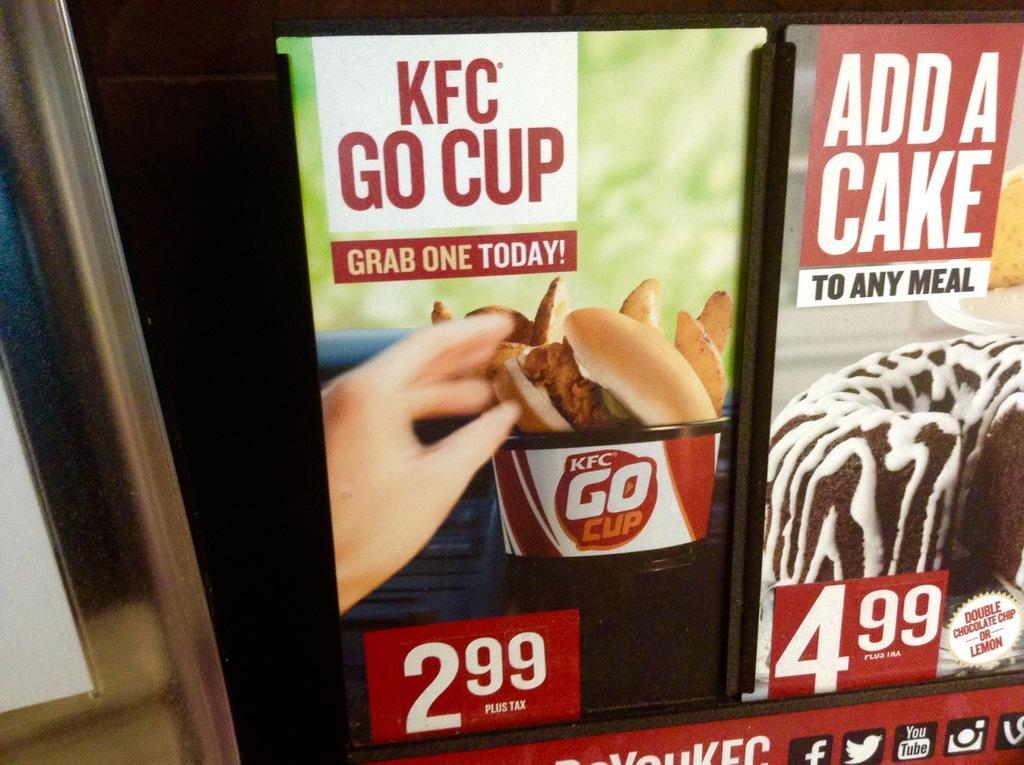Can you describe this image briefly? In this picture we can see posts, pole and in these posters we can see some person hand, food items and in the background it is dark. 